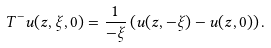<formula> <loc_0><loc_0><loc_500><loc_500>T ^ { - } u ( z , \xi , 0 ) = \frac { 1 } { - \xi } \left ( u ( z , - \xi ) - u ( z , 0 ) \right ) .</formula> 